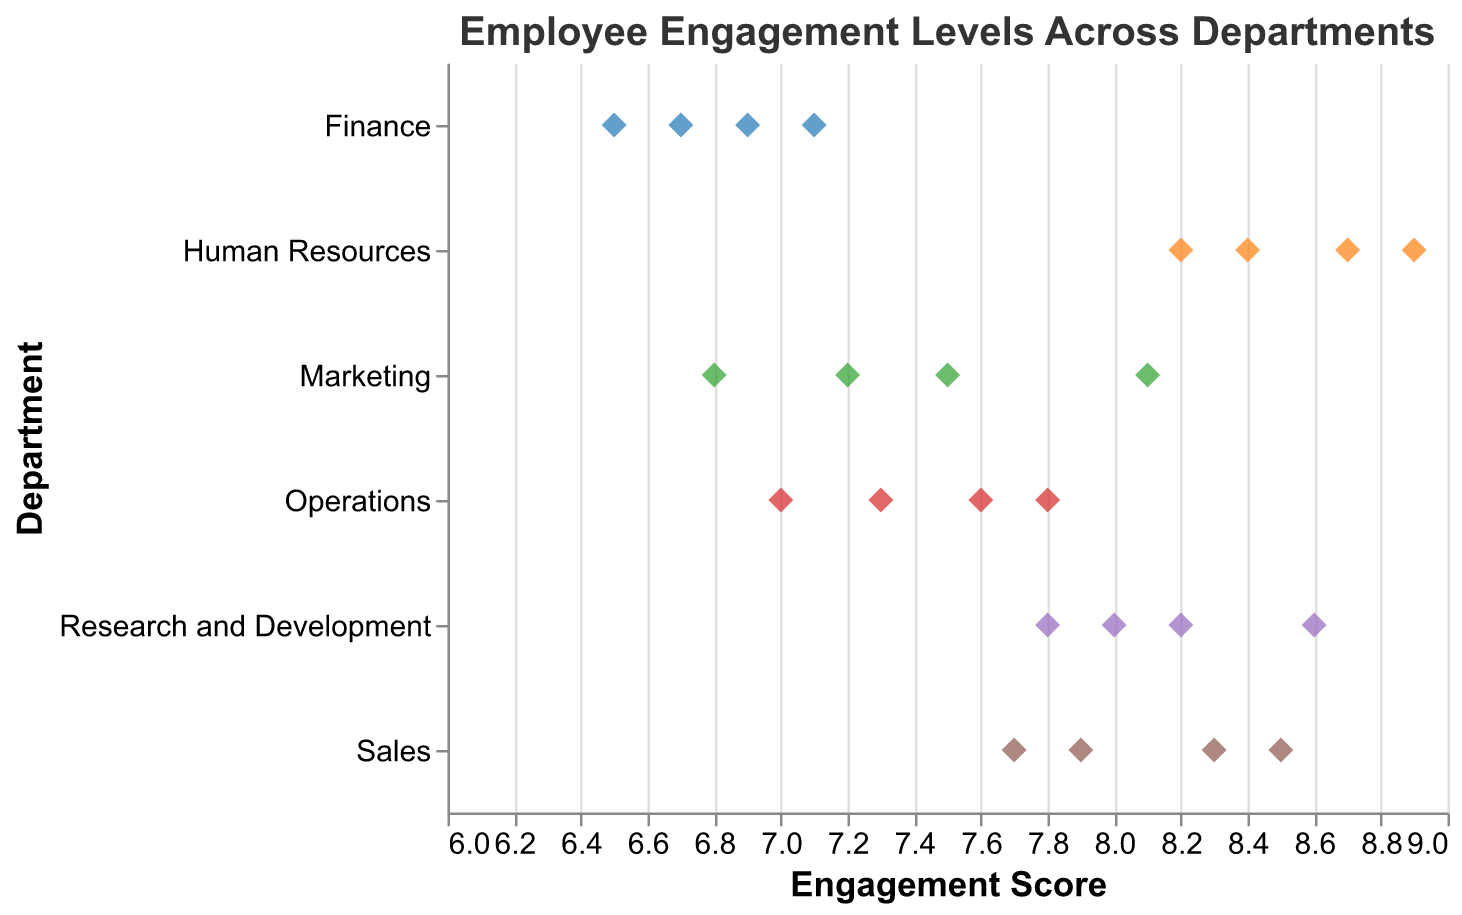What's the title of the plot? The title is positioned at the top of the plot and is given significant emphasis with larger font size. The title states the overall theme of the plot.
Answer: Employee Engagement Levels Across Departments How many departments are represented in the plot? Each unique color and label along the y-axis represent a different department. Counting these labels provides the number of departments.
Answer: 6 Which department has the highest engagement score? The highest engagement score on the x-axis can be identified by finding the rightmost point on the plot. The associated department label on the y-axis indicates the department.
Answer: Human Resources What's the average engagement score for the Marketing department? Add all the engagement scores for Marketing and divide by the number of scores. (7.2 + 6.8 + 8.1 + 7.5) / 4 = 7.4
Answer: 7.4 Which department has the most consistent engagement scores (least variance)? Find the department where the points are closest together along the x-axis, indicating smaller variance in scores.
Answer: Finance By how much does the highest engagement score in Sales exceed the lowest engagement score in Operations? Identify the highest score in Sales (8.5) and the lowest score in Operations (7.0). Subtract the two values. 8.5 - 7.0 = 1.5
Answer: 1.5 Which department has the lowest average engagement score? Calculate the average engagement scores for each department and identify the smallest one. (Marketing: 7.4, Sales: 8.1, Finance: 6.8, Human Resources: 8.55, Operations: 7.425, Research and Development: 8.15)
Answer: Finance Which department has the widest range of engagement scores? Determine the range by subtracting the smallest engagement score from the largest for each department. Compare these ranges to identify the widest.
Answer: Marketing Are there any departments with engagement scores above 9? Check all the engagement scores and verify whether any scores exceed 9.
Answer: No What's the engagement score range for the Operations department? Identify the lowest and highest engagement scores in Operations (7.0 and 7.8), then subtract them. 7.8 - 7.0 = 0.8
Answer: 0.8 